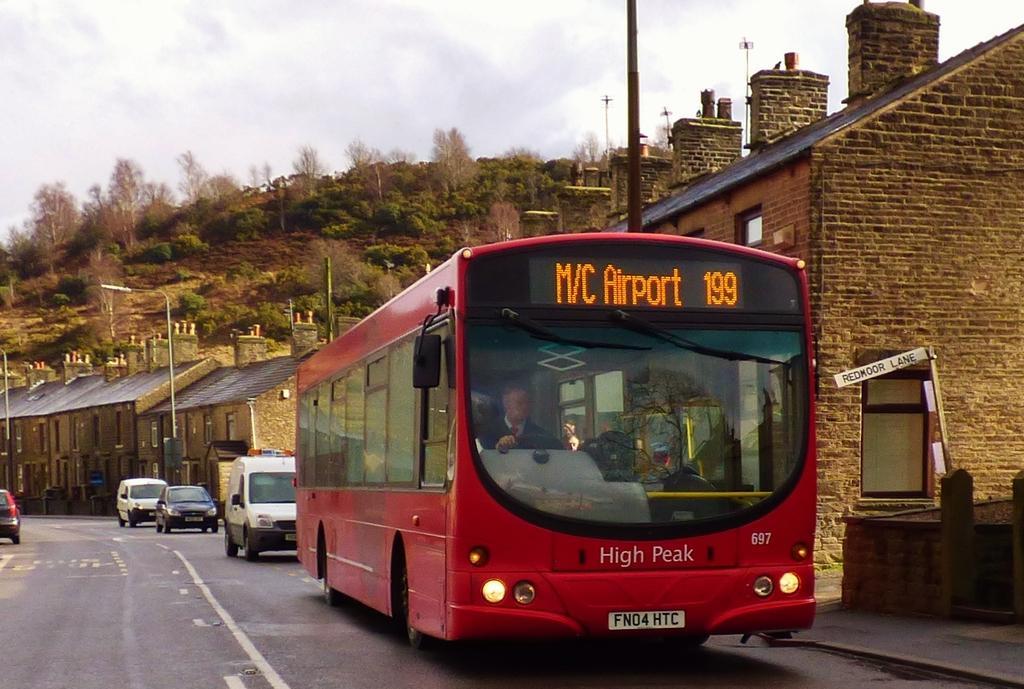Describe this image in one or two sentences. In this image there are vehicles on a road, in the background there are houses, light poles, trees, mountain and the sky. 